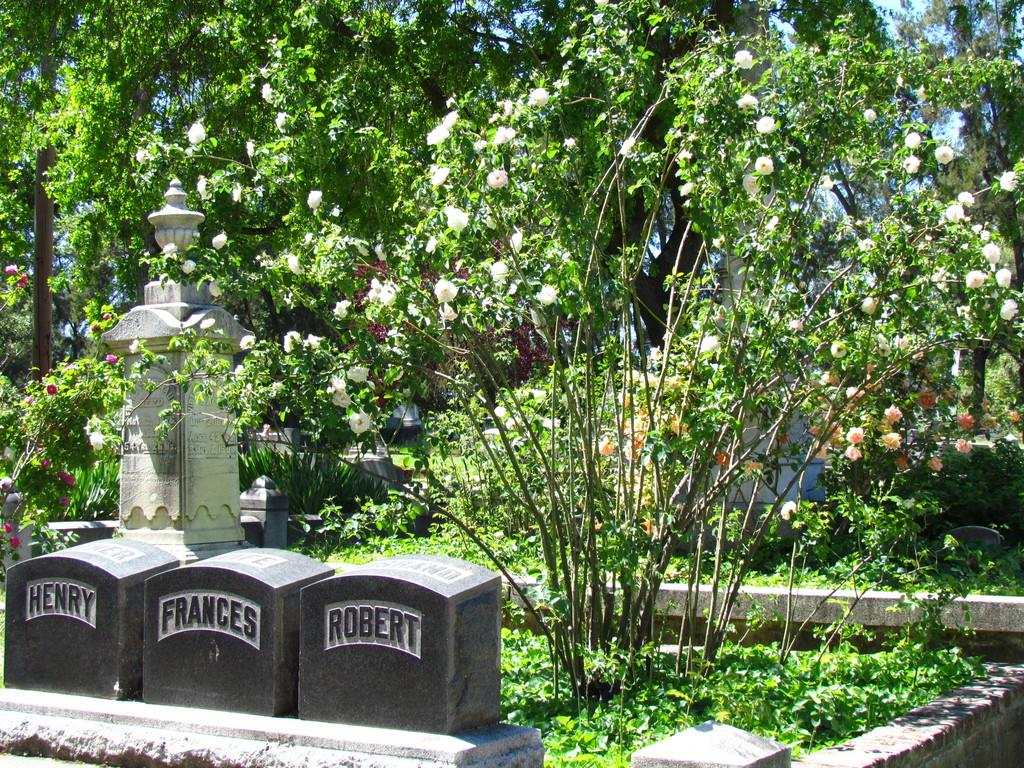What type of objects can be seen at the bottom of the image? There are headstones at the bottom of the image. What is located behind the headstones? There is a pillar behind the headstones. What can be seen in the background of the image? There are many trees in the background of the image. What structure is visible behind the trees? There is a white building visible behind the trees. How many crackers are placed on top of the headstones in the image? There are no crackers present in the image; it features headstones, a pillar, trees, and a white building. What type of meat is hanging from the pillar in the image? There is no meat present in the image; it only features headstones, a pillar, trees, and a white building. 